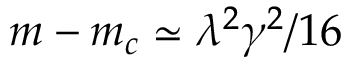Convert formula to latex. <formula><loc_0><loc_0><loc_500><loc_500>m - m _ { c } \simeq \lambda ^ { 2 } \gamma ^ { 2 } / 1 6</formula> 